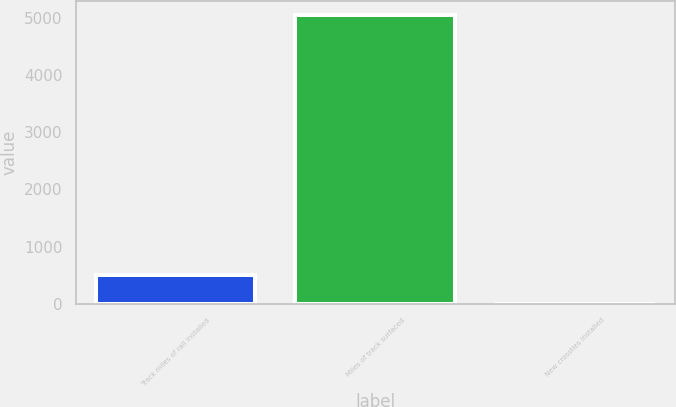Convert chart. <chart><loc_0><loc_0><loc_500><loc_500><bar_chart><fcel>Track miles of rail installed<fcel>Miles of track surfaced<fcel>New crossties installed<nl><fcel>507.75<fcel>5055<fcel>2.5<nl></chart> 